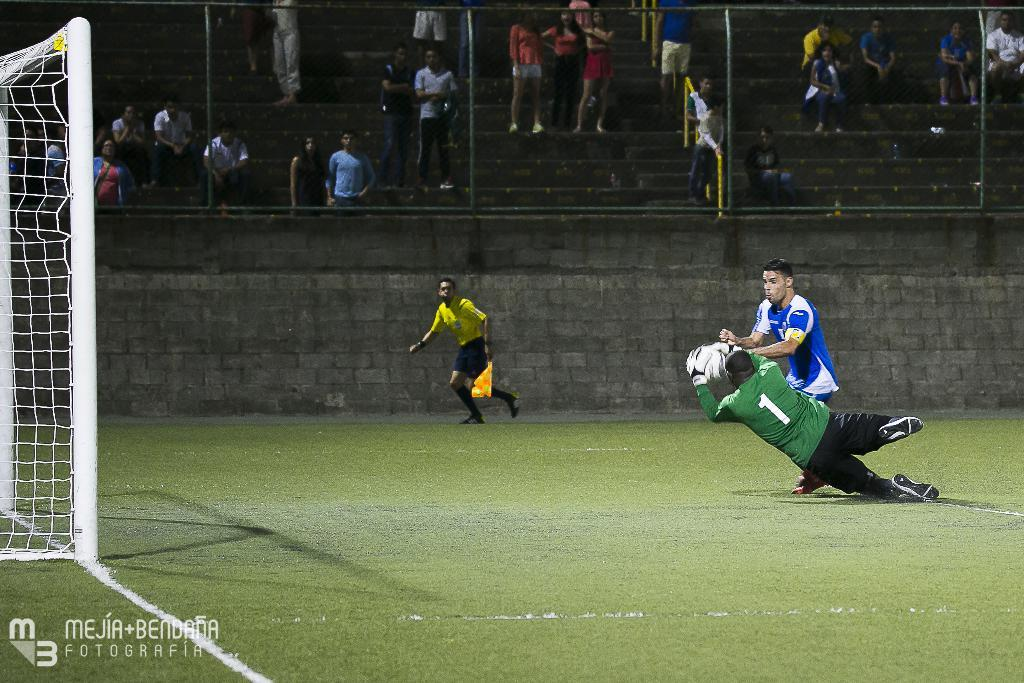<image>
Describe the image concisely. Soccer players in the middle of a game, one with 1 on his jersey. 